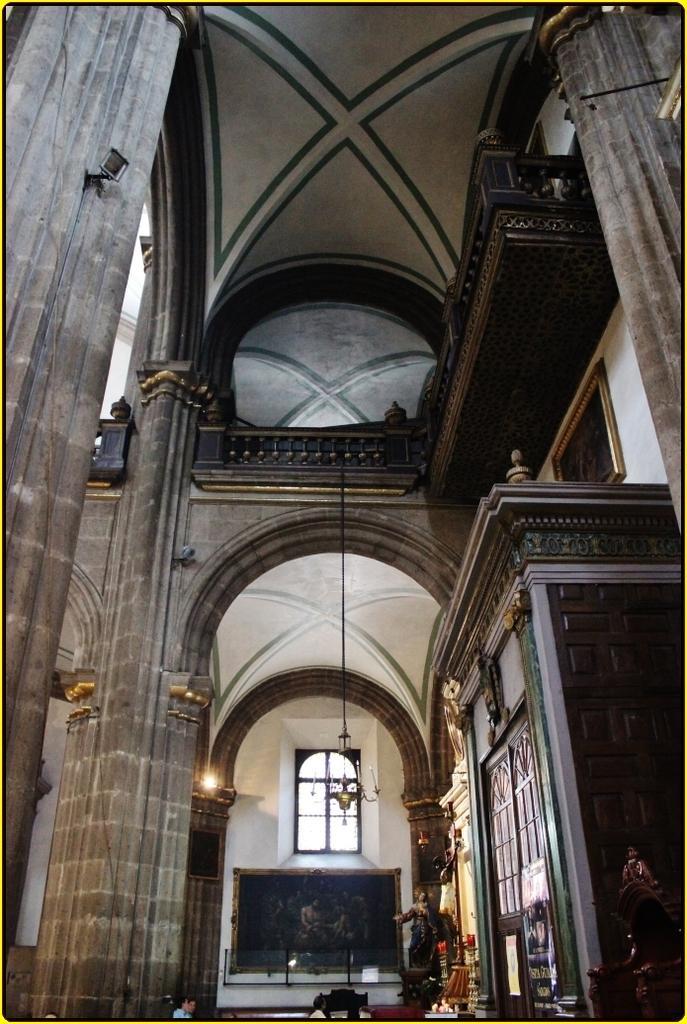Describe this image in one or two sentences. The image is inside a building. Here in the background there is a chandelier hangs on the roof. There is a window. In the right there is a cupboard. There are pillars in the building. 